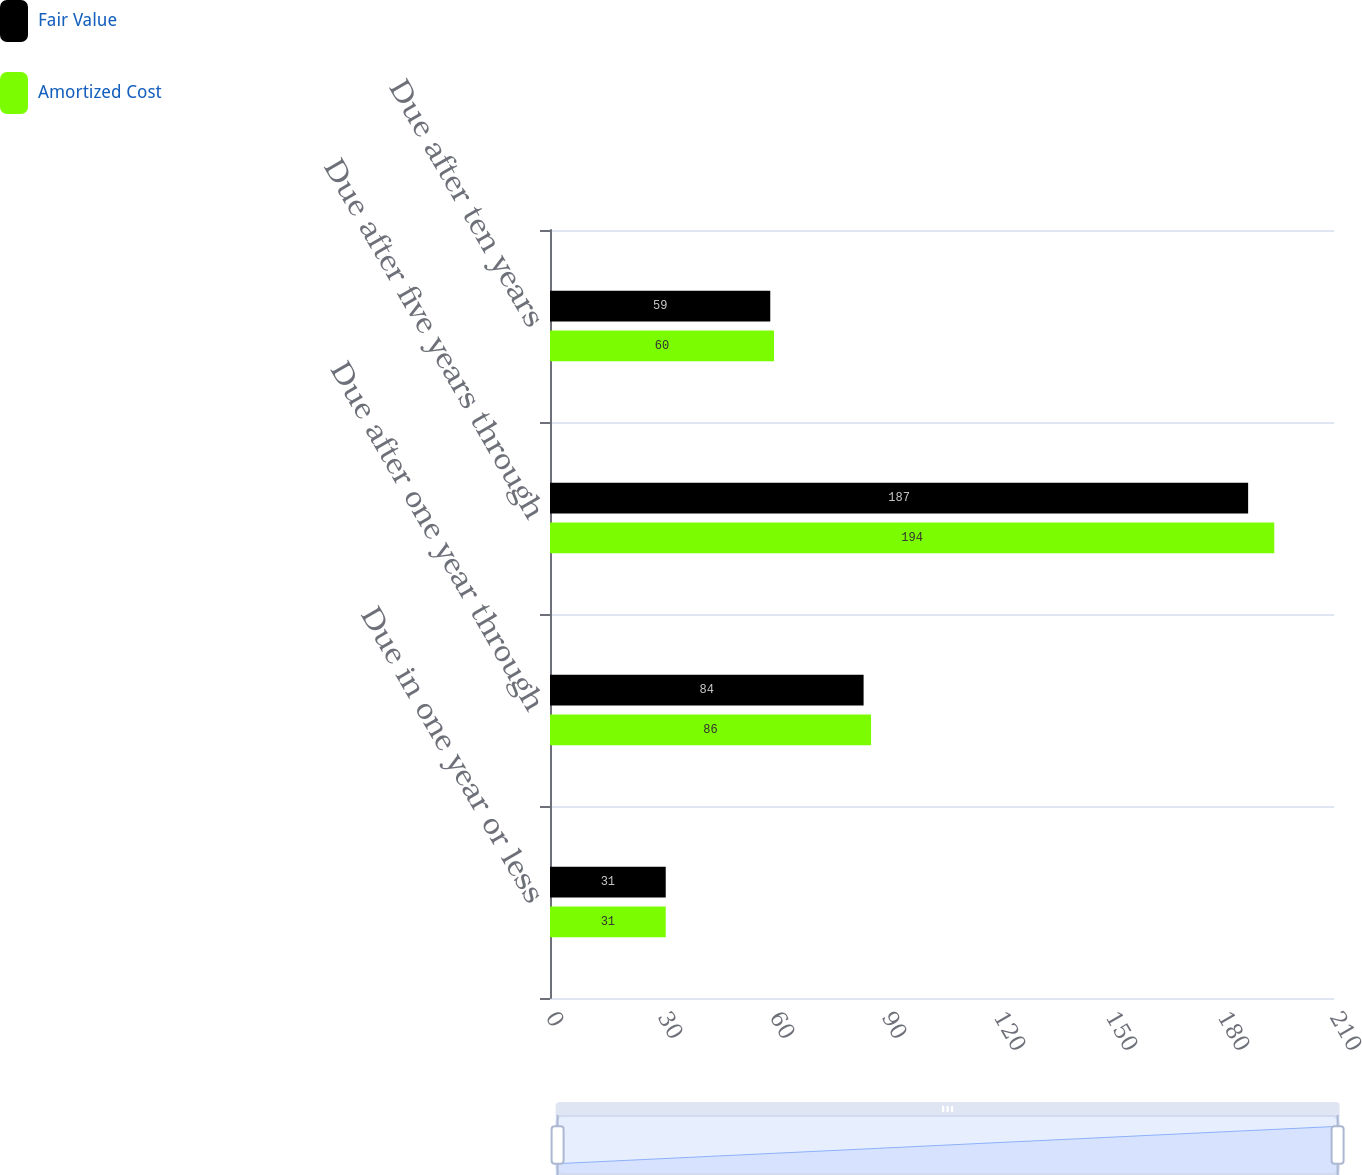Convert chart to OTSL. <chart><loc_0><loc_0><loc_500><loc_500><stacked_bar_chart><ecel><fcel>Due in one year or less<fcel>Due after one year through<fcel>Due after five years through<fcel>Due after ten years<nl><fcel>Fair Value<fcel>31<fcel>84<fcel>187<fcel>59<nl><fcel>Amortized Cost<fcel>31<fcel>86<fcel>194<fcel>60<nl></chart> 